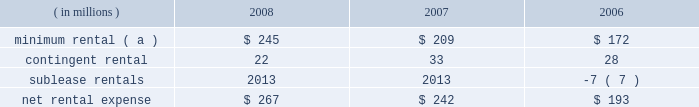Marathon oil corporation notes to consolidated financial statements operating lease rental expense was : ( in millions ) 2008 2007 2006 minimum rental ( a ) $ 245 $ 209 $ 172 .
( a ) excludes $ 5 million , $ 8 million and $ 9 million paid by united states steel in 2008 , 2007 and 2006 on assumed leases .
27 .
Contingencies and commitments we are the subject of , or party to , a number of pending or threatened legal actions , contingencies and commitments involving a variety of matters , including laws and regulations relating to the environment .
Certain of these matters are discussed below .
The ultimate resolution of these contingencies could , individually or in the aggregate , be material to our consolidated financial statements .
However , management believes that we will remain a viable and competitive enterprise even though it is possible that these contingencies could be resolved unfavorably .
Environmental matters 2013 we are subject to federal , state , local and foreign laws and regulations relating to the environment .
These laws generally provide for control of pollutants released into the environment and require responsible parties to undertake remediation of hazardous waste disposal sites .
Penalties may be imposed for noncompliance .
At december 31 , 2008 and 2007 , accrued liabilities for remediation totaled $ 111 million and $ 108 million .
It is not presently possible to estimate the ultimate amount of all remediation costs that might be incurred or the penalties that may be imposed .
Receivables for recoverable costs from certain states , under programs to assist companies in clean-up efforts related to underground storage tanks at retail marketing outlets , were $ 60 and $ 66 million at december 31 , 2008 and 2007 .
We are a defendant , along with other refining companies , in 20 cases arising in three states alleging damages for methyl tertiary-butyl ether ( 201cmtbe 201d ) contamination .
We have also received seven toxic substances control act notice letters involving potential claims in two states .
Such notice letters are often followed by litigation .
Like the cases that were settled in 2008 , the remaining mtbe cases are consolidated in a multidistrict litigation in the southern district of new york for pretrial proceedings .
Nineteen of the remaining cases allege damages to water supply wells , similar to the damages claimed in the settled cases .
In the other remaining case , the state of new jersey is seeking natural resources damages allegedly resulting from contamination of groundwater by mtbe .
This is the only mtbe contamination case in which we are a defendant and natural resources damages are sought .
We are vigorously defending these cases .
We , along with a number of other defendants , have engaged in settlement discussions related to the majority of the cases in which we are a defendant .
We do not expect our share of liability , if any , for the remaining cases to significantly impact our consolidated results of operations , financial position or cash flows .
A lawsuit filed in the united states district court for the southern district of west virginia alleges that our catlettsburg , kentucky , refinery distributed contaminated gasoline to wholesalers and retailers for a period prior to august , 2003 , causing permanent damage to storage tanks , dispensers and related equipment , resulting in lost profits , business disruption and personal and real property damages .
Following the incident , we conducted remediation operations at affected facilities , and we deny that any permanent damages resulted from the incident .
Class action certification was granted in august 2007 .
We have entered into a tentative settlement agreement in this case .
Notice of the proposed settlement has been sent to the class members .
Approval by the court after a fairness hearing is required before the settlement can be finalized .
The fairness hearing is scheduled in the first quarter of 2009 .
The proposed settlement will not significantly impact our consolidated results of operations , financial position or cash flows .
Guarantees 2013 we have provided certain guarantees , direct and indirect , of the indebtedness of other companies .
Under the terms of most of these guarantee arrangements , we would be required to perform should the guaranteed party fail to fulfill its obligations under the specified arrangements .
In addition to these financial guarantees , we also have various performance guarantees related to specific agreements. .
What was the change in millions for receivables for recoverable costs from certain states , under programs to assist companies in clean-up efforts related to underground storage tanks at retail marketing outlets , between december 31 , 2008 and 2007? 
Computations: (60 - 66)
Answer: -6.0. 